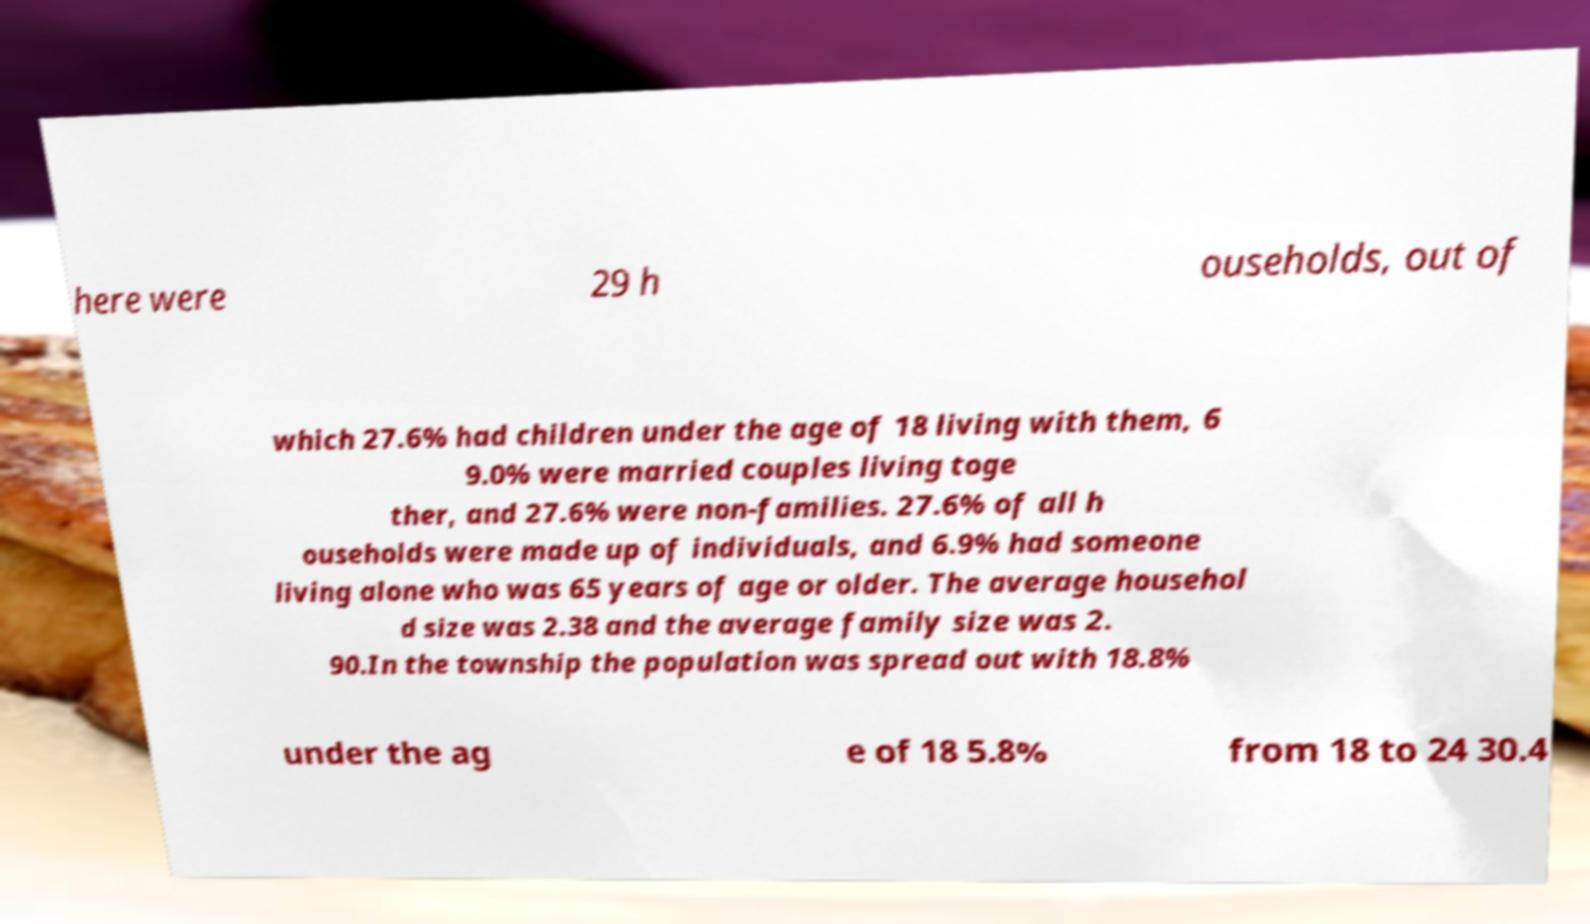I need the written content from this picture converted into text. Can you do that? here were 29 h ouseholds, out of which 27.6% had children under the age of 18 living with them, 6 9.0% were married couples living toge ther, and 27.6% were non-families. 27.6% of all h ouseholds were made up of individuals, and 6.9% had someone living alone who was 65 years of age or older. The average househol d size was 2.38 and the average family size was 2. 90.In the township the population was spread out with 18.8% under the ag e of 18 5.8% from 18 to 24 30.4 